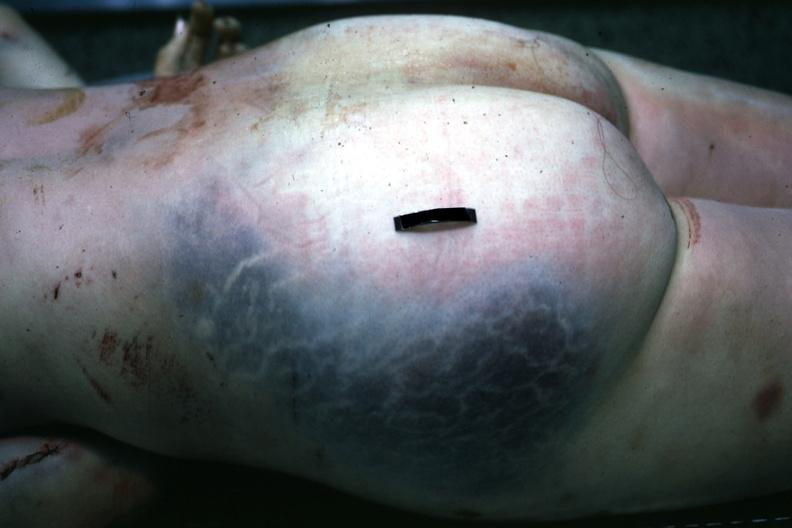what does this image show?
Answer the question using a single word or phrase. Large gluteal hematoma seen at autopsy through the skin 